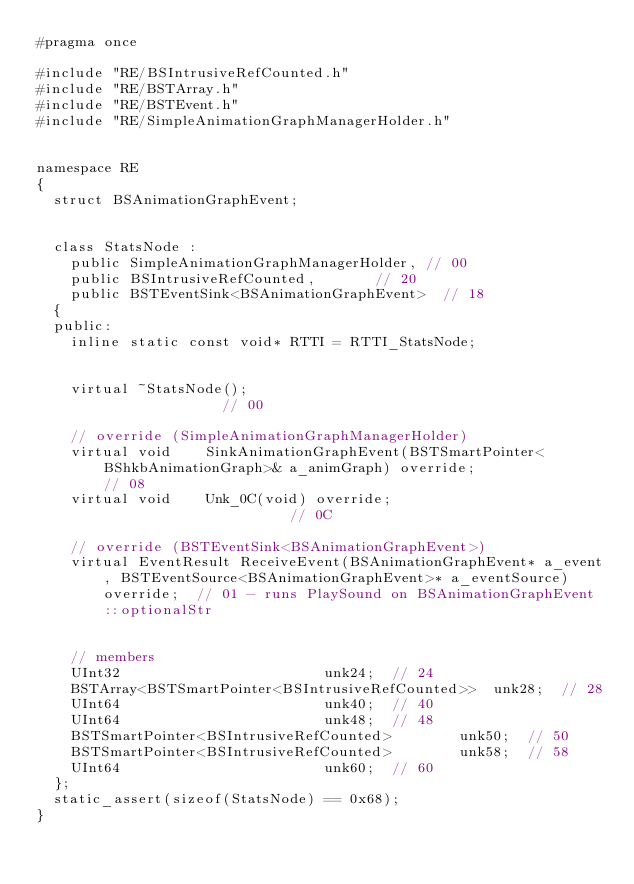<code> <loc_0><loc_0><loc_500><loc_500><_C_>#pragma once

#include "RE/BSIntrusiveRefCounted.h"
#include "RE/BSTArray.h"
#include "RE/BSTEvent.h"
#include "RE/SimpleAnimationGraphManagerHolder.h"


namespace RE
{
	struct BSAnimationGraphEvent;


	class StatsNode :
		public SimpleAnimationGraphManagerHolder,	// 00
		public BSIntrusiveRefCounted,				// 20
		public BSTEventSink<BSAnimationGraphEvent>	// 18
	{
	public:
		inline static const void* RTTI = RTTI_StatsNode;


		virtual ~StatsNode();																												// 00

		// override (SimpleAnimationGraphManagerHolder)
		virtual void		SinkAnimationGraphEvent(BSTSmartPointer<BShkbAnimationGraph>& a_animGraph) override;							// 08
		virtual void		Unk_0C(void) override;																							// 0C

		// override (BSTEventSink<BSAnimationGraphEvent>)
		virtual	EventResult	ReceiveEvent(BSAnimationGraphEvent* a_event, BSTEventSource<BSAnimationGraphEvent>* a_eventSource) override;	// 01 - runs PlaySound on BSAnimationGraphEvent::optionalStr


		// members
		UInt32												unk24;	// 24
		BSTArray<BSTSmartPointer<BSIntrusiveRefCounted>>	unk28;	// 28
		UInt64												unk40;	// 40
		UInt64												unk48;	// 48
		BSTSmartPointer<BSIntrusiveRefCounted>				unk50;	// 50
		BSTSmartPointer<BSIntrusiveRefCounted>				unk58;	// 58
		UInt64												unk60;	// 60
	};
	static_assert(sizeof(StatsNode) == 0x68);
}
</code> 